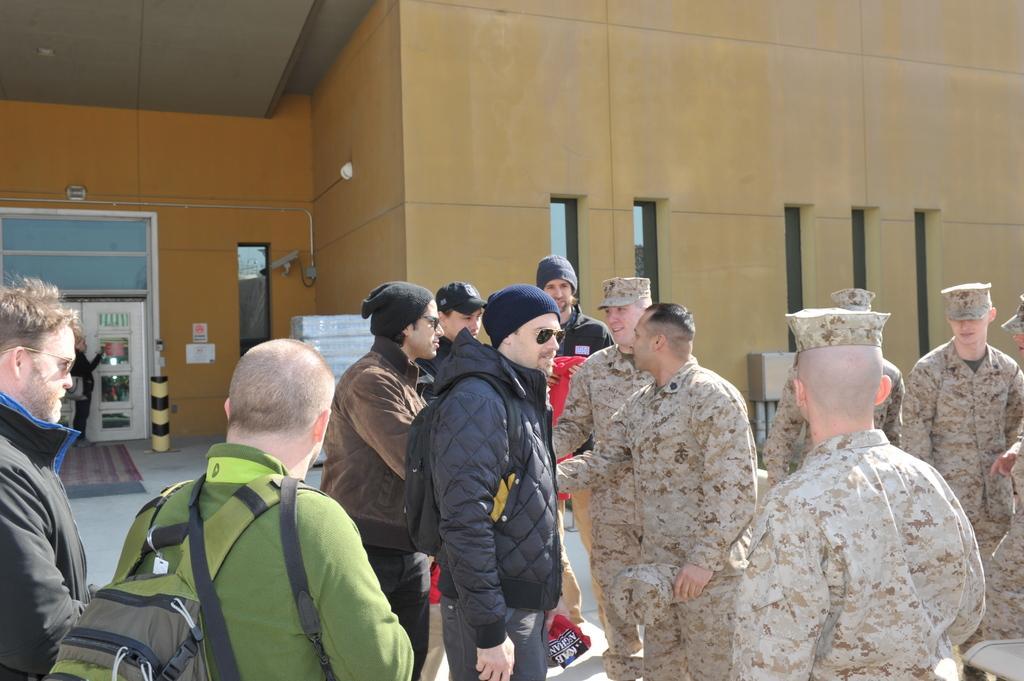Could you give a brief overview of what you see in this image? In this image we can see men. Right side of the image men are wearing army uniform. Left side of the image six men are there. One man is wearing green color dress. The other one is wearing black jacket and carrying black bag. Background of the image building is there and we can see white color door. 